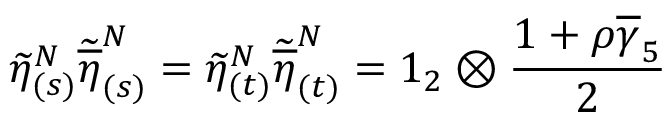<formula> <loc_0><loc_0><loc_500><loc_500>\widetilde { \eta } _ { ( s ) } ^ { N } \widetilde { \overline { \eta } } _ { ( s ) } ^ { N } = \widetilde { \eta } _ { ( t ) } ^ { N } \widetilde { \overline { \eta } } _ { ( t ) } ^ { N } = 1 _ { 2 } \otimes \frac { 1 + \rho \overline { \gamma } _ { 5 } } { 2 }</formula> 